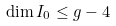Convert formula to latex. <formula><loc_0><loc_0><loc_500><loc_500>\dim I _ { 0 } \leq g - 4</formula> 